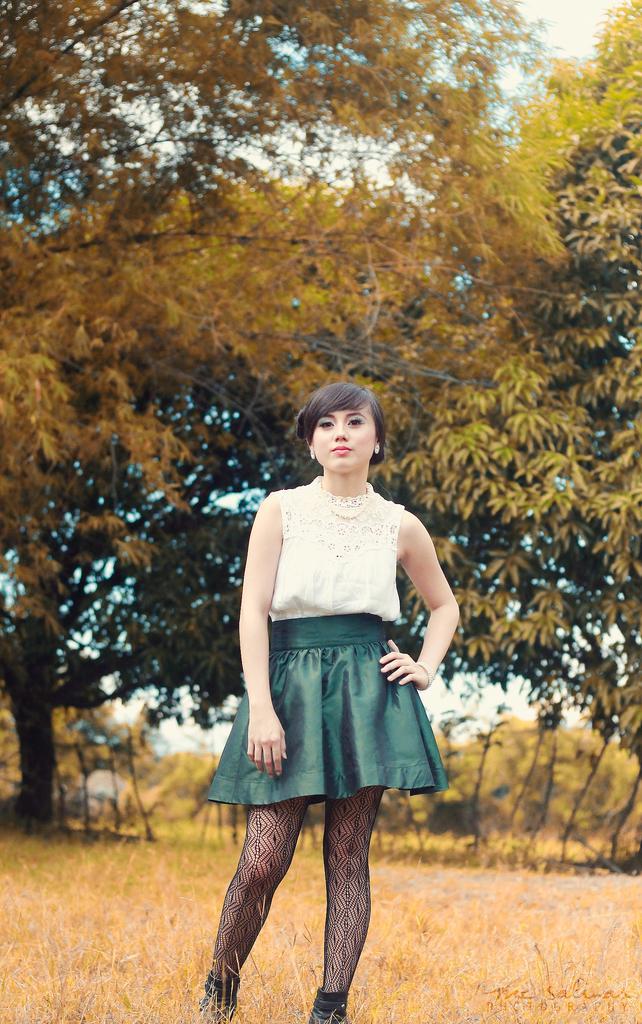In one or two sentences, can you explain what this image depicts? In this image we can see one woman with green and white dress standing on the ground. There are some trees, bushes, plants and grass on the ground. At the top there is the sky. 